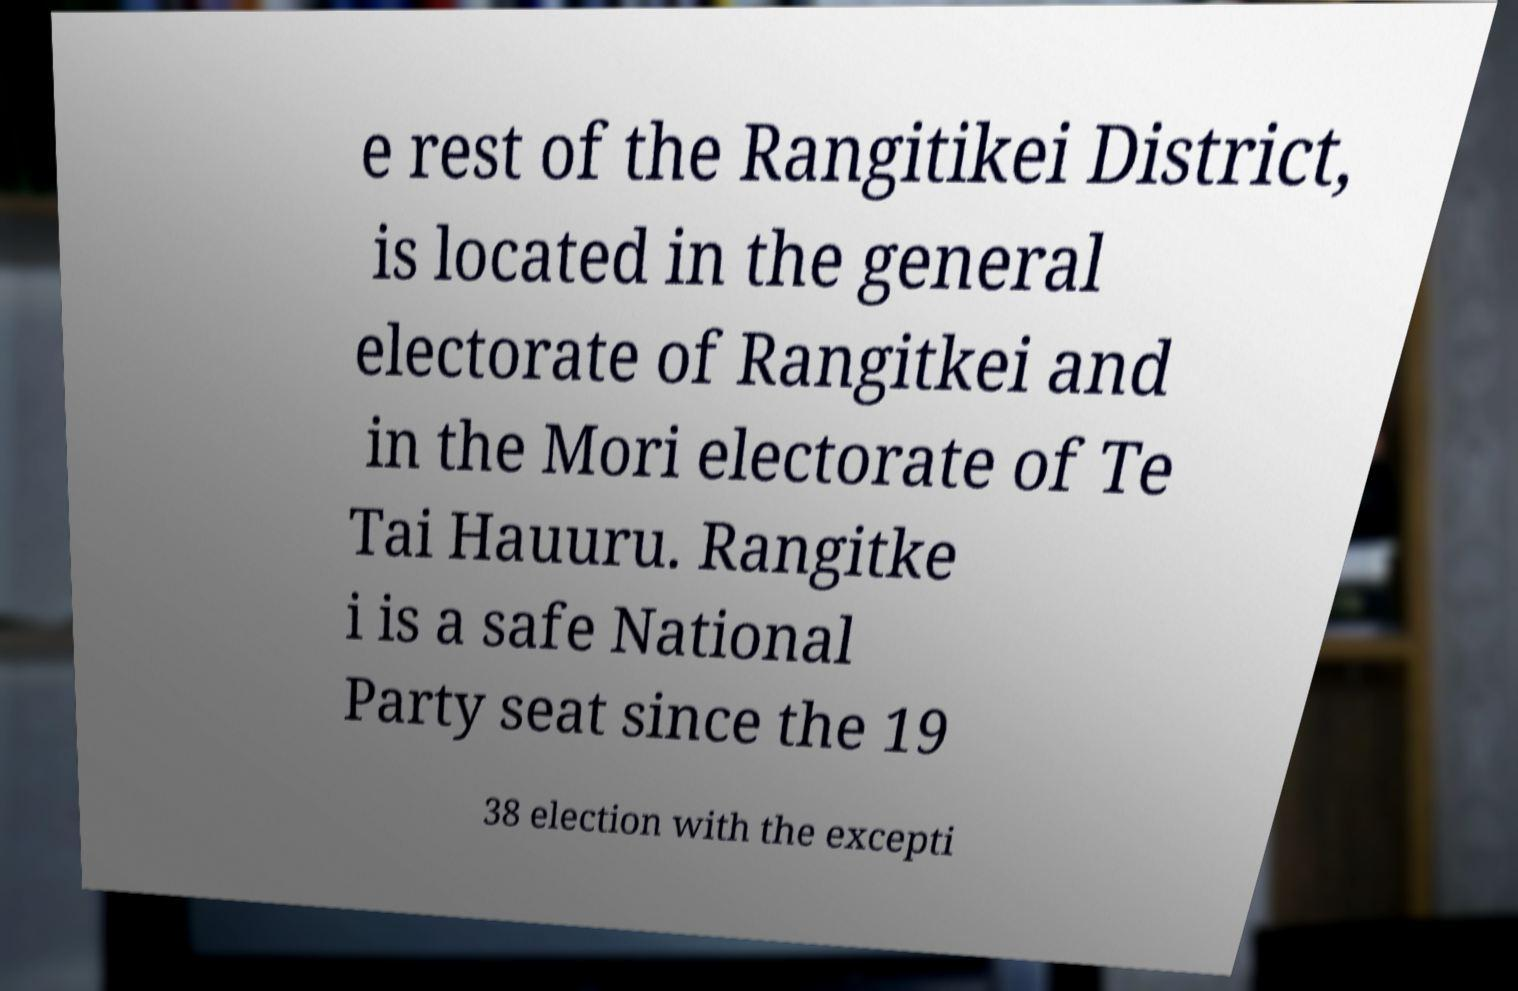Can you accurately transcribe the text from the provided image for me? e rest of the Rangitikei District, is located in the general electorate of Rangitkei and in the Mori electorate of Te Tai Hauuru. Rangitke i is a safe National Party seat since the 19 38 election with the excepti 